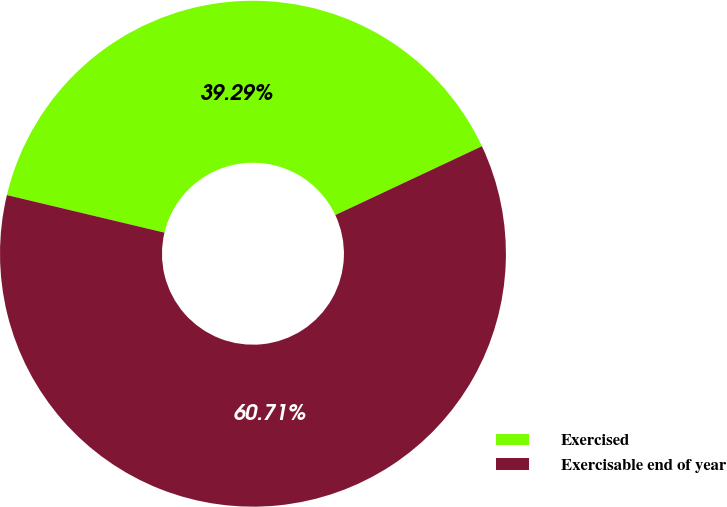<chart> <loc_0><loc_0><loc_500><loc_500><pie_chart><fcel>Exercised<fcel>Exercisable end of year<nl><fcel>39.29%<fcel>60.71%<nl></chart> 